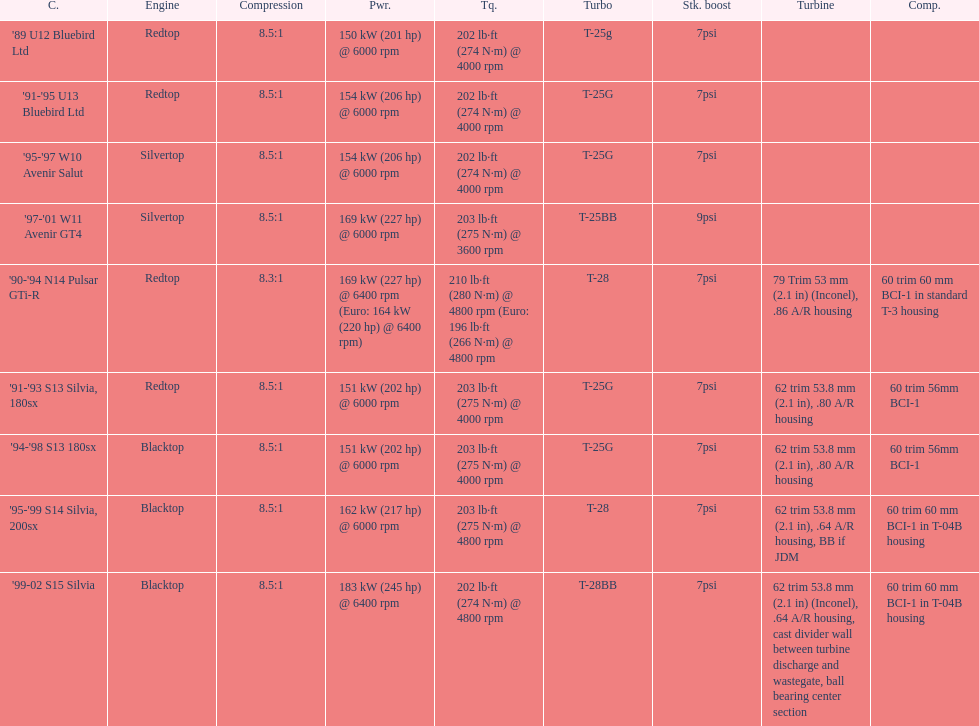What is his/her compression for the 90-94 n14 pulsar gti-r? 8.3:1. 